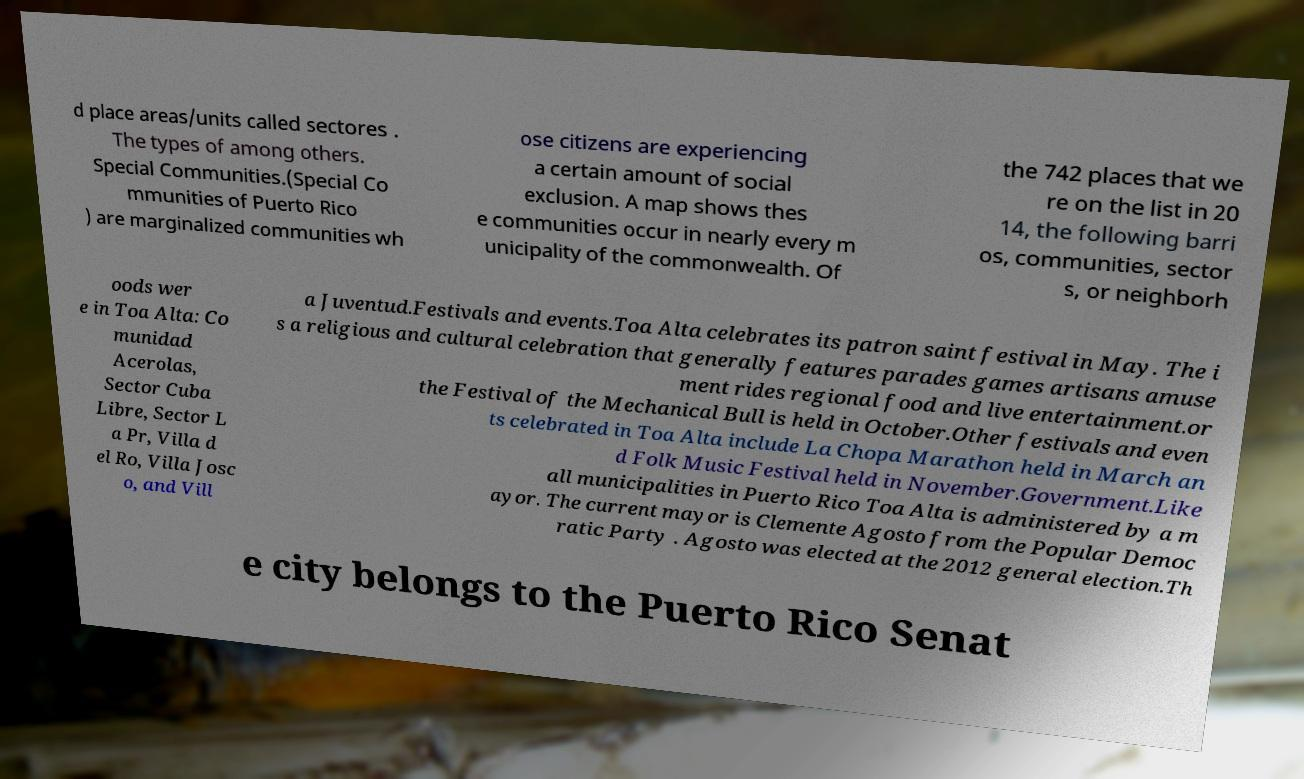I need the written content from this picture converted into text. Can you do that? d place areas/units called sectores . The types of among others. Special Communities.(Special Co mmunities of Puerto Rico ) are marginalized communities wh ose citizens are experiencing a certain amount of social exclusion. A map shows thes e communities occur in nearly every m unicipality of the commonwealth. Of the 742 places that we re on the list in 20 14, the following barri os, communities, sector s, or neighborh oods wer e in Toa Alta: Co munidad Acerolas, Sector Cuba Libre, Sector L a Pr, Villa d el Ro, Villa Josc o, and Vill a Juventud.Festivals and events.Toa Alta celebrates its patron saint festival in May. The i s a religious and cultural celebration that generally features parades games artisans amuse ment rides regional food and live entertainment.or the Festival of the Mechanical Bull is held in October.Other festivals and even ts celebrated in Toa Alta include La Chopa Marathon held in March an d Folk Music Festival held in November.Government.Like all municipalities in Puerto Rico Toa Alta is administered by a m ayor. The current mayor is Clemente Agosto from the Popular Democ ratic Party . Agosto was elected at the 2012 general election.Th e city belongs to the Puerto Rico Senat 